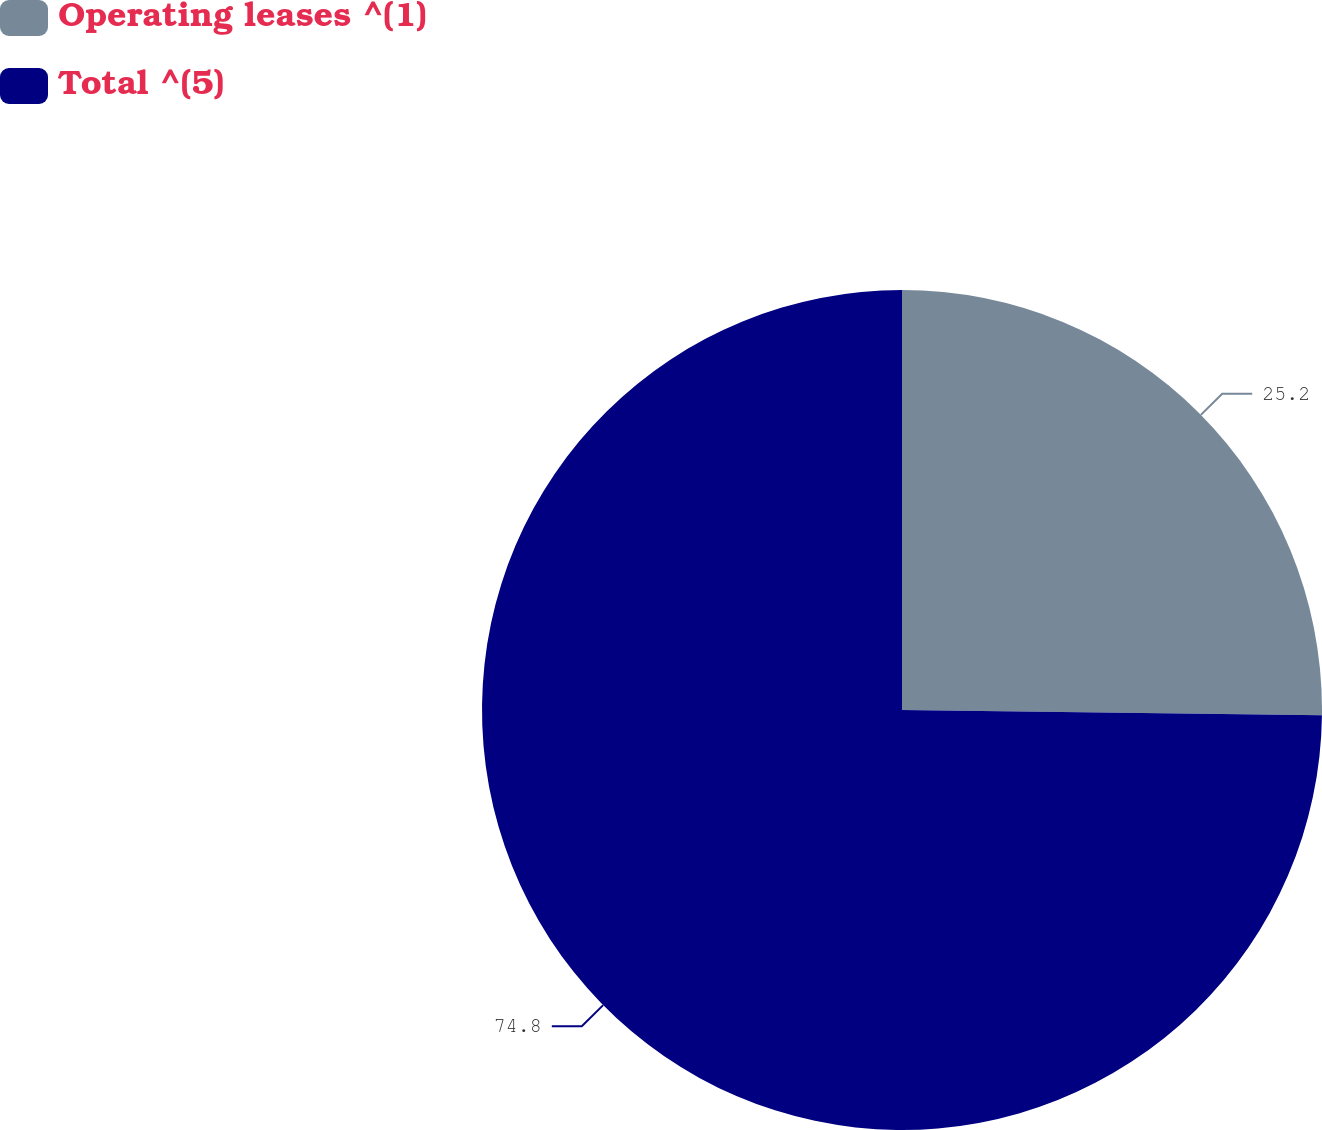Convert chart to OTSL. <chart><loc_0><loc_0><loc_500><loc_500><pie_chart><fcel>Operating leases ^(1)<fcel>Total ^(5)<nl><fcel>25.2%<fcel>74.8%<nl></chart> 